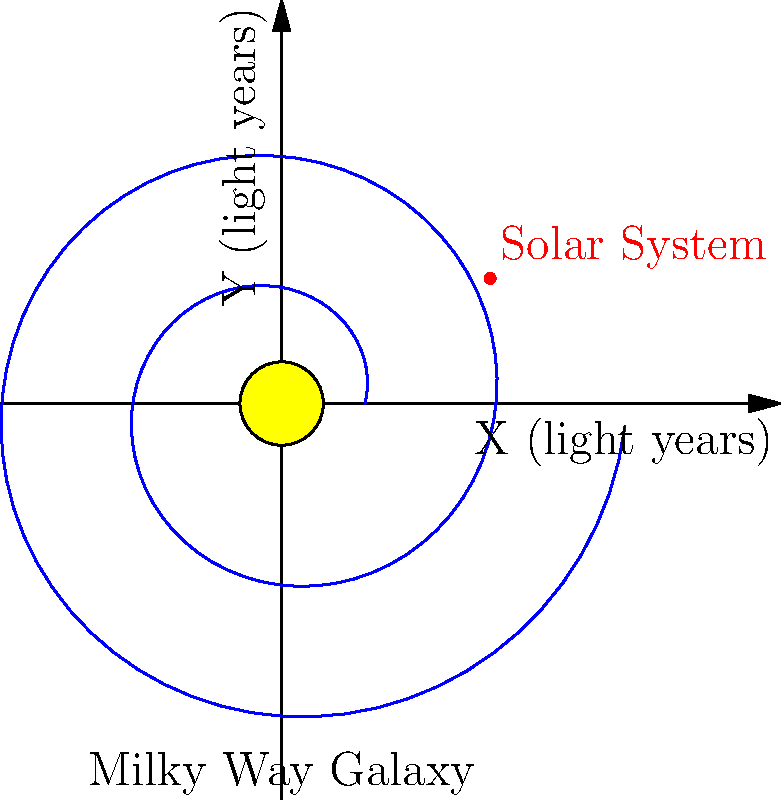As a digital media specialist for religious organizations, you're creating content about the vastness of creation. In this context, describe the position of our solar system within the Milky Way galaxy based on the diagram, and explain how this relates to our understanding of the universe's scale. To answer this question, let's break down the information provided in the diagram and relate it to our understanding of the universe's scale:

1. Galaxy structure: The diagram shows a spiral galaxy, representing the Milky Way. The spiral arms are visible in blue, with a yellow core at the center.

2. Solar System position: Our solar system is represented by the red dot, located away from the galaxy's center but within one of the spiral arms.

3. Distance from the center: Based on the diagram, our solar system appears to be roughly 2/3 of the way from the center to the edge of the visible galaxy.

4. Scale implications: 
   a. The Milky Way galaxy is approximately 100,000 light-years in diameter.
   b. Our solar system's position suggests we're about 25,000-30,000 light-years from the galactic center.
   c. One light-year is approximately $9.46 \times 10^{12}$ km or $5.88 \times 10^{12}$ miles.

5. Vastness of creation: This diagram illustrates that our solar system is just a tiny part of an enormous galaxy. The Milky Way itself is just one of billions of galaxies in the observable universe.

6. Religious context: For many religious perspectives, the scale and complexity of the universe can be seen as a testament to the grandeur of creation, inspiring awe and wonder at the cosmic order.

Understanding our position within the galaxy helps put into perspective the immense scale of the universe, which can be a powerful tool for engaging audiences in discussions about faith, creation, and humanity's place in the cosmos.
Answer: Our solar system is located in a spiral arm, about 25,000-30,000 light-years from the galactic center, illustrating the vast scale of creation. 